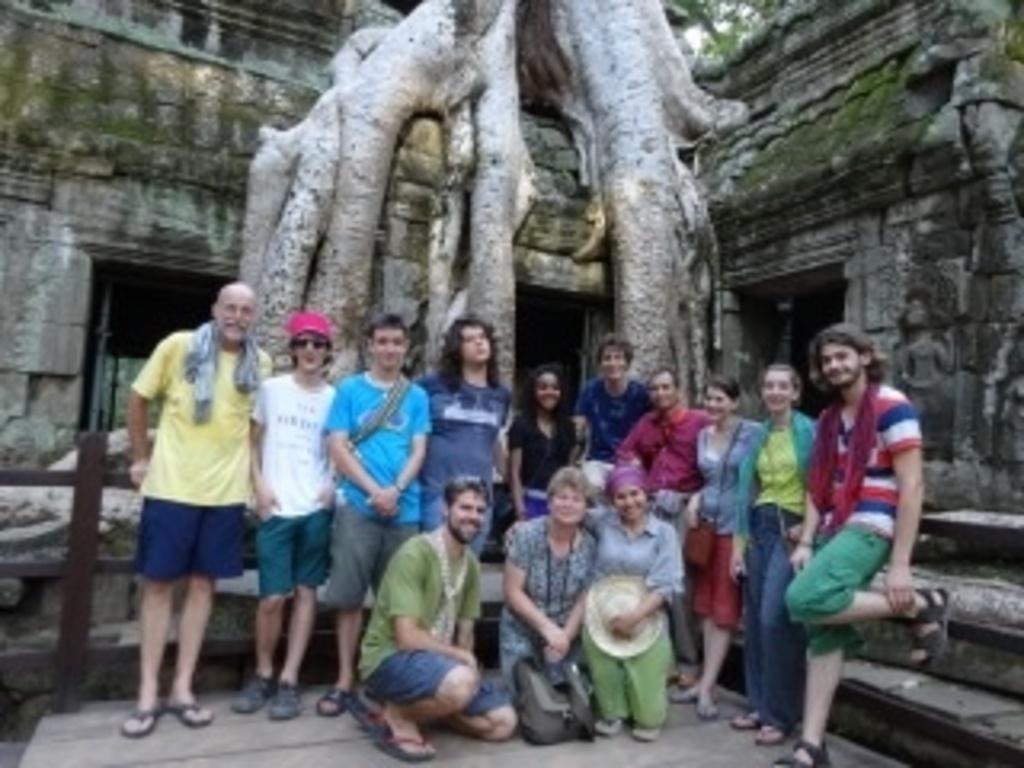Who are the people standing in the image? There are foreigners standing in the image. What are the people sitting in front of the foreigners doing? There are three people sitting in front of the foreigners, but their actions are not specified in the facts. What is the old structure visible in the image? There is an old temple visible in the image. What is the condition of the old temple? The old temple has a mold on it. What is located on the old temple? There is a tree on the old temple. What decision is being made by the school in the image? There is no mention of a school in the image, so it is not possible to answer a question about a decision being made by a school. What verse is being recited by the people in the image? There is no indication of any recitation or verse in the image. 